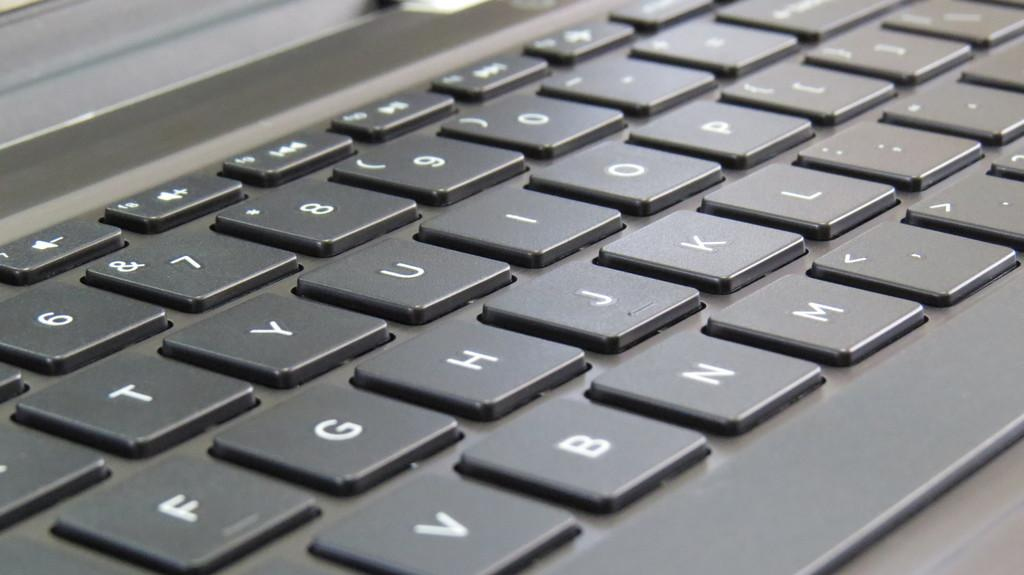<image>
Create a compact narrative representing the image presented. Black keyboard with white keys that has the number 6 on the top left. 